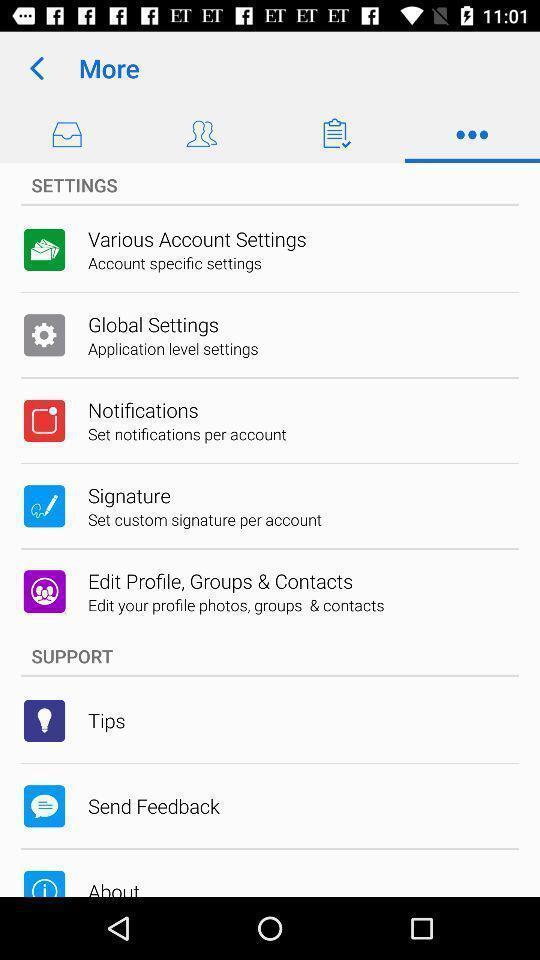What is the overall content of this screenshot? Screen showing settings. 